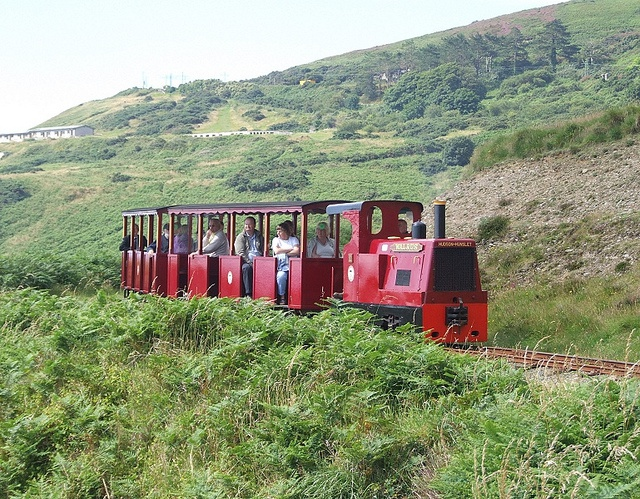Describe the objects in this image and their specific colors. I can see train in white, maroon, black, gray, and lightpink tones, people in white, gray, black, darkgray, and lightgray tones, people in white, gray, and black tones, people in white, gray, darkgray, lightgray, and black tones, and people in white, gray, and black tones in this image. 